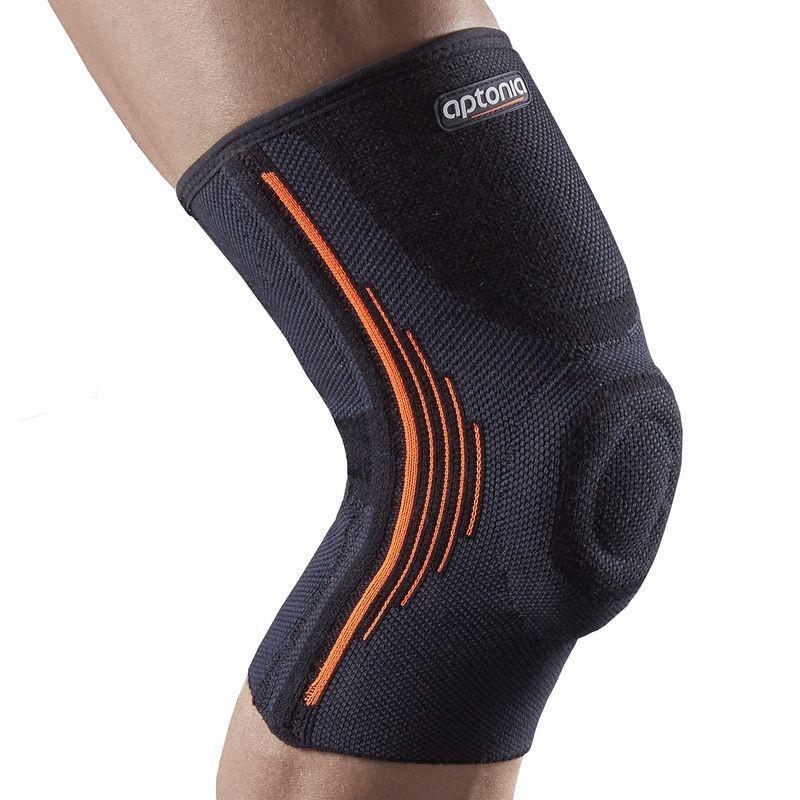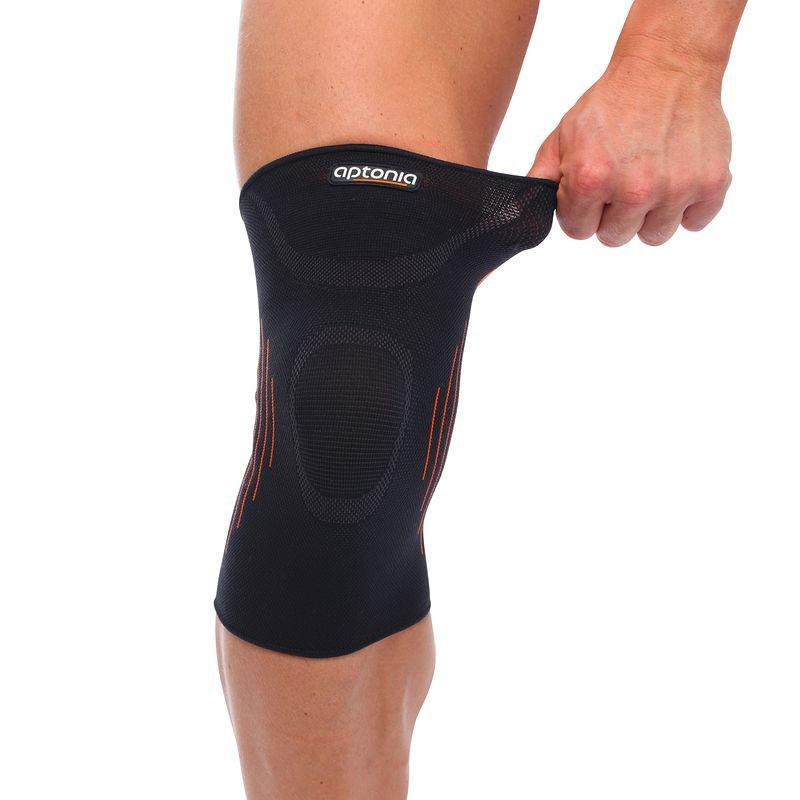The first image is the image on the left, the second image is the image on the right. Evaluate the accuracy of this statement regarding the images: "The right image contains at least one pair of legs.". Is it true? Answer yes or no. No. 